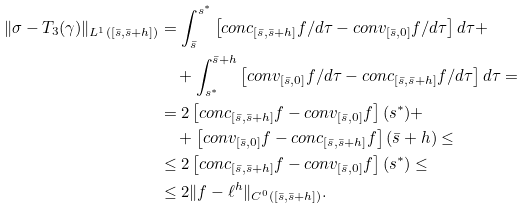Convert formula to latex. <formula><loc_0><loc_0><loc_500><loc_500>\| \sigma - T _ { 3 } ( \gamma ) \| _ { L ^ { 1 } ( [ \bar { s } , \bar { s } + h ] ) } & = \int _ { \bar { s } } ^ { s ^ { \ast } } \left [ c o n c _ { [ \bar { s } , \bar { s } + h ] } f / d \tau - c o n v _ { [ \bar { s } , 0 ] } f / d \tau \right ] d \tau + \\ & \quad + \int _ { s ^ { \ast } } ^ { \bar { s } + h } \left [ c o n v _ { [ \bar { s } , 0 ] } f / d \tau - c o n c _ { [ \bar { s } , \bar { s } + h ] } f / d \tau \right ] d \tau = \\ & = 2 \left [ c o n c _ { [ \bar { s } , \bar { s } + h ] } f - c o n v _ { [ \bar { s } , 0 ] } f \right ] ( s ^ { \ast } ) + \\ & \quad + \left [ c o n v _ { [ \bar { s } , 0 ] } f - c o n c _ { [ \bar { s } , \bar { s } + h ] } f \right ] ( \bar { s } + h ) \leq \\ & \leq 2 \left [ c o n c _ { [ \bar { s } , \bar { s } + h ] } f - c o n v _ { [ \bar { s } , 0 ] } f \right ] ( s ^ { \ast } ) \leq \\ & \leq 2 \| f - \ell ^ { h } \| _ { C ^ { 0 } ( [ \bar { s } , \bar { s } + h ] ) } . \\</formula> 